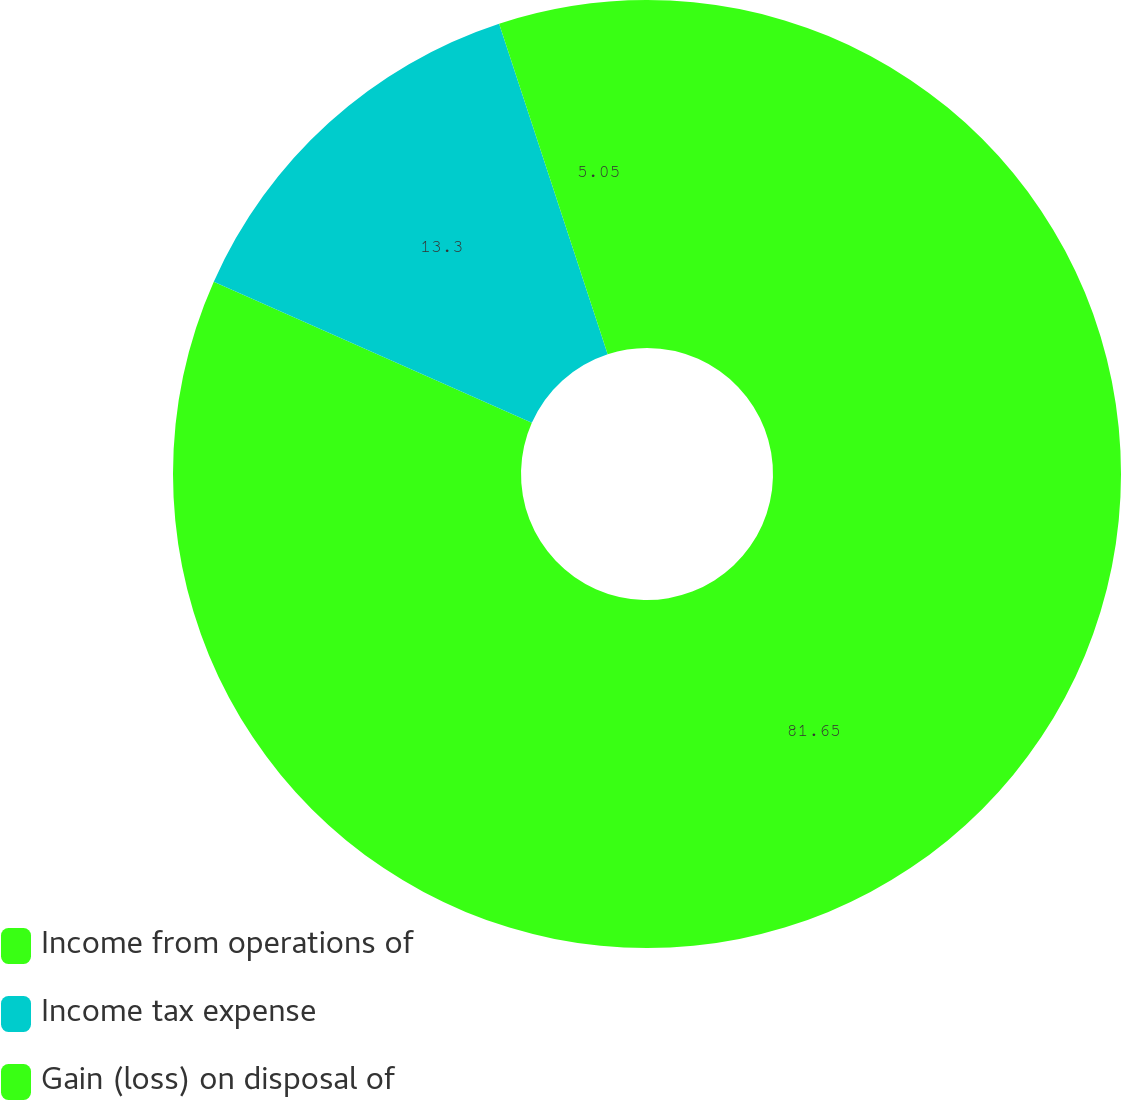Convert chart. <chart><loc_0><loc_0><loc_500><loc_500><pie_chart><fcel>Income from operations of<fcel>Income tax expense<fcel>Gain (loss) on disposal of<nl><fcel>81.65%<fcel>13.3%<fcel>5.05%<nl></chart> 